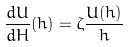Convert formula to latex. <formula><loc_0><loc_0><loc_500><loc_500>\frac { d U } { d H } ( h ) = \zeta \frac { U ( h ) } { h }</formula> 